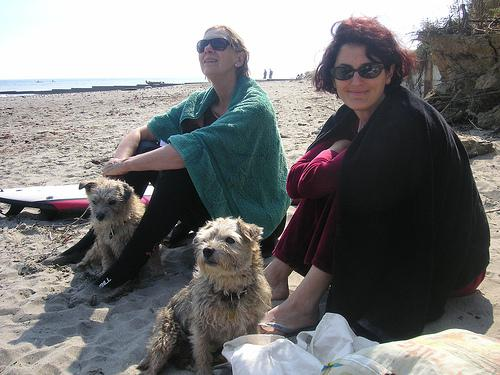Question: what are the women wearing?
Choices:
A. Sunglasses.
B. Hat.
C. Earrings.
D. Glasses.
Answer with the letter. Answer: A 